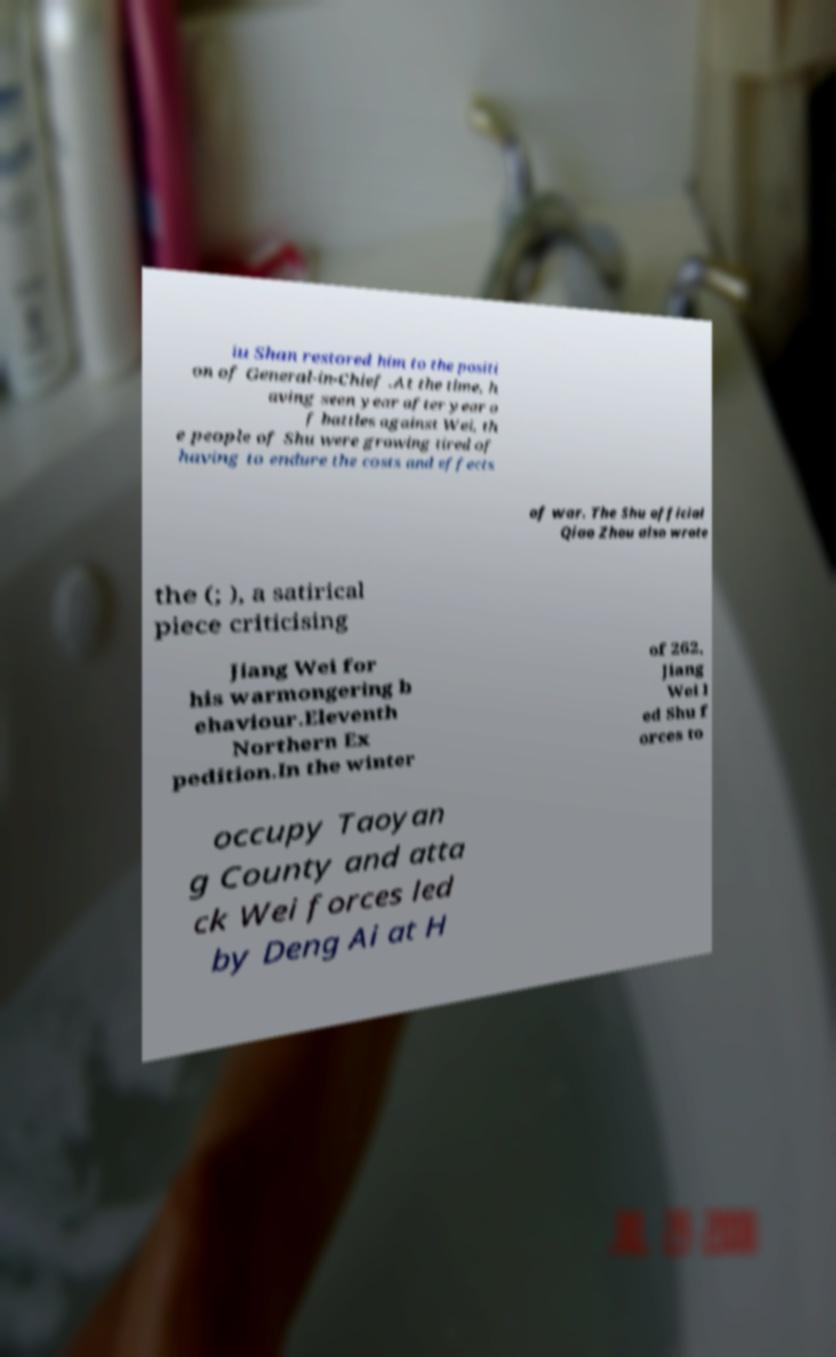Please read and relay the text visible in this image. What does it say? iu Shan restored him to the positi on of General-in-Chief .At the time, h aving seen year after year o f battles against Wei, th e people of Shu were growing tired of having to endure the costs and effects of war. The Shu official Qiao Zhou also wrote the (; ), a satirical piece criticising Jiang Wei for his warmongering b ehaviour.Eleventh Northern Ex pedition.In the winter of 262, Jiang Wei l ed Shu f orces to occupy Taoyan g County and atta ck Wei forces led by Deng Ai at H 